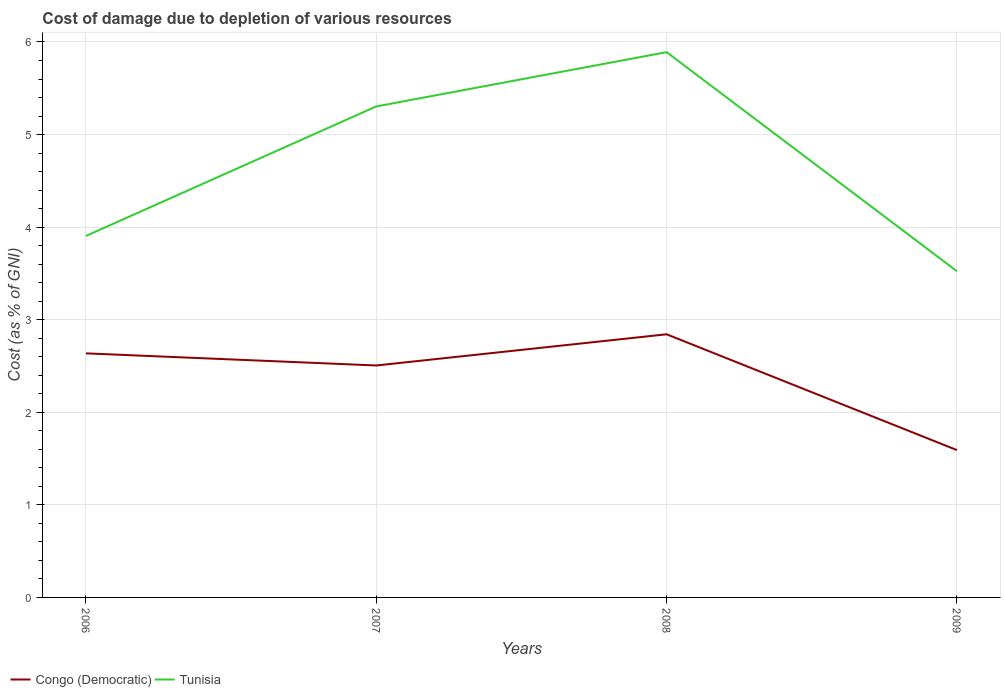How many different coloured lines are there?
Your answer should be very brief. 2. Across all years, what is the maximum cost of damage caused due to the depletion of various resources in Congo (Democratic)?
Give a very brief answer. 1.59. What is the total cost of damage caused due to the depletion of various resources in Tunisia in the graph?
Provide a short and direct response. -1.99. What is the difference between the highest and the second highest cost of damage caused due to the depletion of various resources in Tunisia?
Your answer should be very brief. 2.37. What is the difference between the highest and the lowest cost of damage caused due to the depletion of various resources in Tunisia?
Your response must be concise. 2. How many lines are there?
Your answer should be very brief. 2. What is the difference between two consecutive major ticks on the Y-axis?
Provide a succinct answer. 1. Are the values on the major ticks of Y-axis written in scientific E-notation?
Ensure brevity in your answer.  No. Does the graph contain grids?
Your response must be concise. Yes. How are the legend labels stacked?
Your response must be concise. Horizontal. What is the title of the graph?
Offer a terse response. Cost of damage due to depletion of various resources. Does "Marshall Islands" appear as one of the legend labels in the graph?
Give a very brief answer. No. What is the label or title of the Y-axis?
Give a very brief answer. Cost (as % of GNI). What is the Cost (as % of GNI) of Congo (Democratic) in 2006?
Provide a short and direct response. 2.64. What is the Cost (as % of GNI) in Tunisia in 2006?
Your answer should be compact. 3.9. What is the Cost (as % of GNI) of Congo (Democratic) in 2007?
Offer a terse response. 2.51. What is the Cost (as % of GNI) in Tunisia in 2007?
Your answer should be compact. 5.3. What is the Cost (as % of GNI) in Congo (Democratic) in 2008?
Provide a succinct answer. 2.84. What is the Cost (as % of GNI) of Tunisia in 2008?
Give a very brief answer. 5.89. What is the Cost (as % of GNI) in Congo (Democratic) in 2009?
Your response must be concise. 1.59. What is the Cost (as % of GNI) in Tunisia in 2009?
Provide a short and direct response. 3.52. Across all years, what is the maximum Cost (as % of GNI) of Congo (Democratic)?
Give a very brief answer. 2.84. Across all years, what is the maximum Cost (as % of GNI) in Tunisia?
Offer a very short reply. 5.89. Across all years, what is the minimum Cost (as % of GNI) in Congo (Democratic)?
Make the answer very short. 1.59. Across all years, what is the minimum Cost (as % of GNI) of Tunisia?
Offer a very short reply. 3.52. What is the total Cost (as % of GNI) of Congo (Democratic) in the graph?
Make the answer very short. 9.58. What is the total Cost (as % of GNI) in Tunisia in the graph?
Provide a short and direct response. 18.62. What is the difference between the Cost (as % of GNI) in Congo (Democratic) in 2006 and that in 2007?
Ensure brevity in your answer.  0.13. What is the difference between the Cost (as % of GNI) of Tunisia in 2006 and that in 2007?
Provide a short and direct response. -1.4. What is the difference between the Cost (as % of GNI) in Congo (Democratic) in 2006 and that in 2008?
Your answer should be very brief. -0.21. What is the difference between the Cost (as % of GNI) of Tunisia in 2006 and that in 2008?
Make the answer very short. -1.99. What is the difference between the Cost (as % of GNI) in Congo (Democratic) in 2006 and that in 2009?
Give a very brief answer. 1.04. What is the difference between the Cost (as % of GNI) in Tunisia in 2006 and that in 2009?
Ensure brevity in your answer.  0.38. What is the difference between the Cost (as % of GNI) of Congo (Democratic) in 2007 and that in 2008?
Your response must be concise. -0.34. What is the difference between the Cost (as % of GNI) of Tunisia in 2007 and that in 2008?
Keep it short and to the point. -0.59. What is the difference between the Cost (as % of GNI) in Congo (Democratic) in 2007 and that in 2009?
Keep it short and to the point. 0.91. What is the difference between the Cost (as % of GNI) of Tunisia in 2007 and that in 2009?
Give a very brief answer. 1.78. What is the difference between the Cost (as % of GNI) of Congo (Democratic) in 2008 and that in 2009?
Make the answer very short. 1.25. What is the difference between the Cost (as % of GNI) of Tunisia in 2008 and that in 2009?
Provide a succinct answer. 2.37. What is the difference between the Cost (as % of GNI) in Congo (Democratic) in 2006 and the Cost (as % of GNI) in Tunisia in 2007?
Your answer should be very brief. -2.67. What is the difference between the Cost (as % of GNI) in Congo (Democratic) in 2006 and the Cost (as % of GNI) in Tunisia in 2008?
Ensure brevity in your answer.  -3.25. What is the difference between the Cost (as % of GNI) of Congo (Democratic) in 2006 and the Cost (as % of GNI) of Tunisia in 2009?
Make the answer very short. -0.89. What is the difference between the Cost (as % of GNI) of Congo (Democratic) in 2007 and the Cost (as % of GNI) of Tunisia in 2008?
Provide a short and direct response. -3.38. What is the difference between the Cost (as % of GNI) of Congo (Democratic) in 2007 and the Cost (as % of GNI) of Tunisia in 2009?
Your response must be concise. -1.02. What is the difference between the Cost (as % of GNI) of Congo (Democratic) in 2008 and the Cost (as % of GNI) of Tunisia in 2009?
Offer a very short reply. -0.68. What is the average Cost (as % of GNI) of Congo (Democratic) per year?
Ensure brevity in your answer.  2.39. What is the average Cost (as % of GNI) in Tunisia per year?
Give a very brief answer. 4.66. In the year 2006, what is the difference between the Cost (as % of GNI) in Congo (Democratic) and Cost (as % of GNI) in Tunisia?
Ensure brevity in your answer.  -1.27. In the year 2007, what is the difference between the Cost (as % of GNI) of Congo (Democratic) and Cost (as % of GNI) of Tunisia?
Your answer should be very brief. -2.8. In the year 2008, what is the difference between the Cost (as % of GNI) of Congo (Democratic) and Cost (as % of GNI) of Tunisia?
Provide a succinct answer. -3.05. In the year 2009, what is the difference between the Cost (as % of GNI) in Congo (Democratic) and Cost (as % of GNI) in Tunisia?
Your answer should be very brief. -1.93. What is the ratio of the Cost (as % of GNI) in Congo (Democratic) in 2006 to that in 2007?
Your answer should be compact. 1.05. What is the ratio of the Cost (as % of GNI) of Tunisia in 2006 to that in 2007?
Provide a succinct answer. 0.74. What is the ratio of the Cost (as % of GNI) in Congo (Democratic) in 2006 to that in 2008?
Your response must be concise. 0.93. What is the ratio of the Cost (as % of GNI) of Tunisia in 2006 to that in 2008?
Keep it short and to the point. 0.66. What is the ratio of the Cost (as % of GNI) of Congo (Democratic) in 2006 to that in 2009?
Offer a terse response. 1.66. What is the ratio of the Cost (as % of GNI) of Tunisia in 2006 to that in 2009?
Provide a succinct answer. 1.11. What is the ratio of the Cost (as % of GNI) of Congo (Democratic) in 2007 to that in 2008?
Your answer should be compact. 0.88. What is the ratio of the Cost (as % of GNI) in Tunisia in 2007 to that in 2008?
Your answer should be very brief. 0.9. What is the ratio of the Cost (as % of GNI) of Congo (Democratic) in 2007 to that in 2009?
Your answer should be compact. 1.57. What is the ratio of the Cost (as % of GNI) in Tunisia in 2007 to that in 2009?
Provide a short and direct response. 1.51. What is the ratio of the Cost (as % of GNI) of Congo (Democratic) in 2008 to that in 2009?
Offer a terse response. 1.79. What is the ratio of the Cost (as % of GNI) in Tunisia in 2008 to that in 2009?
Your response must be concise. 1.67. What is the difference between the highest and the second highest Cost (as % of GNI) of Congo (Democratic)?
Offer a very short reply. 0.21. What is the difference between the highest and the second highest Cost (as % of GNI) of Tunisia?
Your response must be concise. 0.59. What is the difference between the highest and the lowest Cost (as % of GNI) in Congo (Democratic)?
Provide a succinct answer. 1.25. What is the difference between the highest and the lowest Cost (as % of GNI) of Tunisia?
Give a very brief answer. 2.37. 